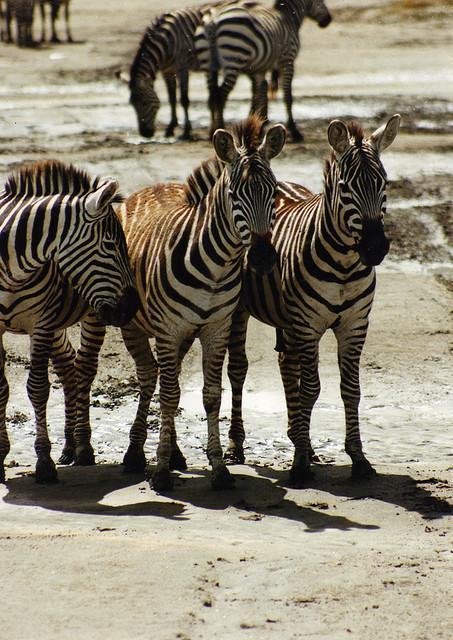How many tails can you see?
Give a very brief answer. 1. How many zebras are there?
Give a very brief answer. 5. How many zebras are facing the camera?
Give a very brief answer. 2. How many zebras are in the photo?
Give a very brief answer. 5. 